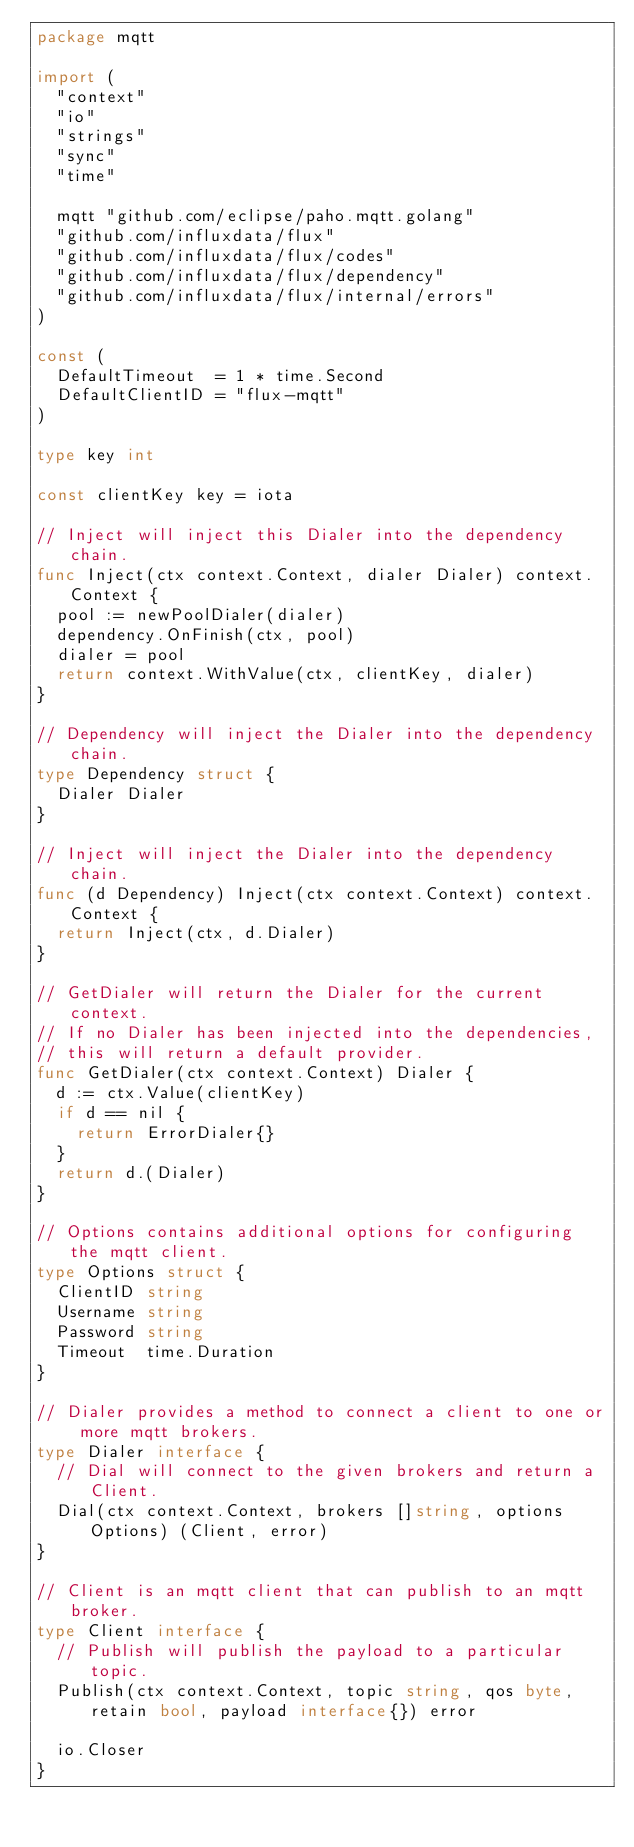<code> <loc_0><loc_0><loc_500><loc_500><_Go_>package mqtt

import (
	"context"
	"io"
	"strings"
	"sync"
	"time"

	mqtt "github.com/eclipse/paho.mqtt.golang"
	"github.com/influxdata/flux"
	"github.com/influxdata/flux/codes"
	"github.com/influxdata/flux/dependency"
	"github.com/influxdata/flux/internal/errors"
)

const (
	DefaultTimeout  = 1 * time.Second
	DefaultClientID = "flux-mqtt"
)

type key int

const clientKey key = iota

// Inject will inject this Dialer into the dependency chain.
func Inject(ctx context.Context, dialer Dialer) context.Context {
	pool := newPoolDialer(dialer)
	dependency.OnFinish(ctx, pool)
	dialer = pool
	return context.WithValue(ctx, clientKey, dialer)
}

// Dependency will inject the Dialer into the dependency chain.
type Dependency struct {
	Dialer Dialer
}

// Inject will inject the Dialer into the dependency chain.
func (d Dependency) Inject(ctx context.Context) context.Context {
	return Inject(ctx, d.Dialer)
}

// GetDialer will return the Dialer for the current context.
// If no Dialer has been injected into the dependencies,
// this will return a default provider.
func GetDialer(ctx context.Context) Dialer {
	d := ctx.Value(clientKey)
	if d == nil {
		return ErrorDialer{}
	}
	return d.(Dialer)
}

// Options contains additional options for configuring the mqtt client.
type Options struct {
	ClientID string
	Username string
	Password string
	Timeout  time.Duration
}

// Dialer provides a method to connect a client to one or more mqtt brokers.
type Dialer interface {
	// Dial will connect to the given brokers and return a Client.
	Dial(ctx context.Context, brokers []string, options Options) (Client, error)
}

// Client is an mqtt client that can publish to an mqtt broker.
type Client interface {
	// Publish will publish the payload to a particular topic.
	Publish(ctx context.Context, topic string, qos byte, retain bool, payload interface{}) error

	io.Closer
}
</code> 